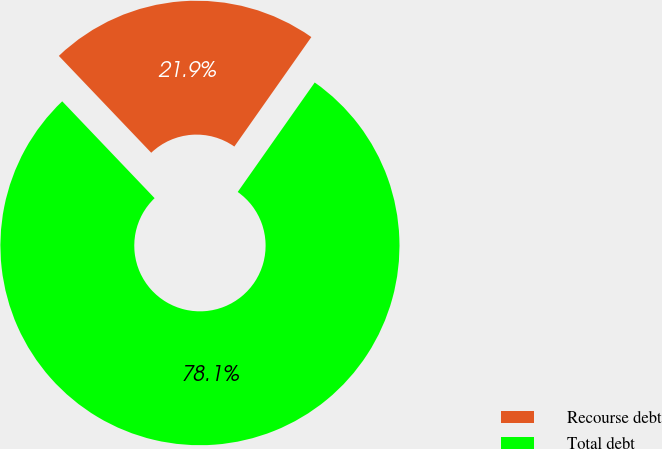<chart> <loc_0><loc_0><loc_500><loc_500><pie_chart><fcel>Recourse debt<fcel>Total debt<nl><fcel>21.88%<fcel>78.12%<nl></chart> 